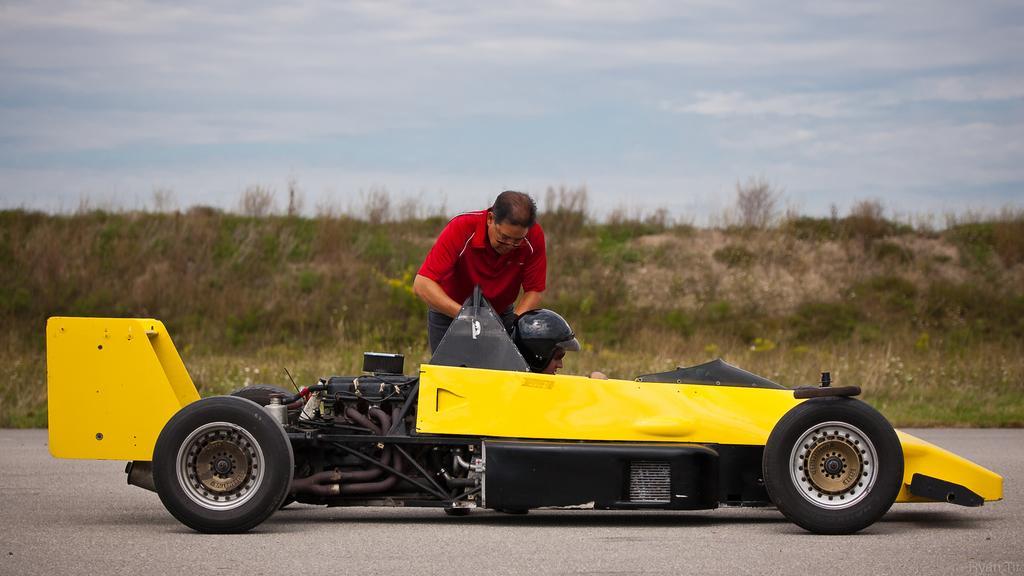Please provide a concise description of this image. In this image I can see a road in the front and on it I can see a yellow colour vehicle and a man. I can see one more person is sitting in this vehicle and I can see this person is wearing a black colour helmet. In the background I can see grass, clouds and the sky. 